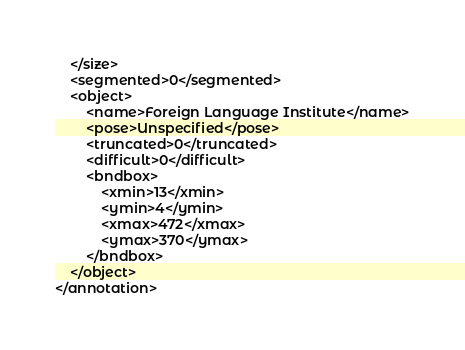<code> <loc_0><loc_0><loc_500><loc_500><_XML_>	</size>
	<segmented>0</segmented>
	<object>
		<name>Foreign Language Institute</name>
		<pose>Unspecified</pose>
		<truncated>0</truncated>
		<difficult>0</difficult>
		<bndbox>
			<xmin>13</xmin>
			<ymin>4</ymin>
			<xmax>472</xmax>
			<ymax>370</ymax>
		</bndbox>
	</object>
</annotation>
</code> 